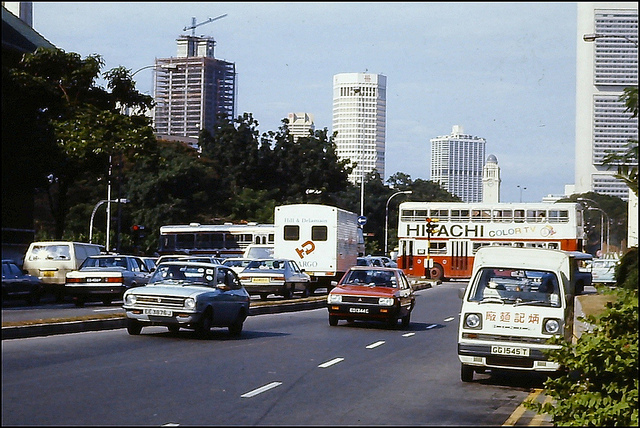How many trucks can you see? 3 